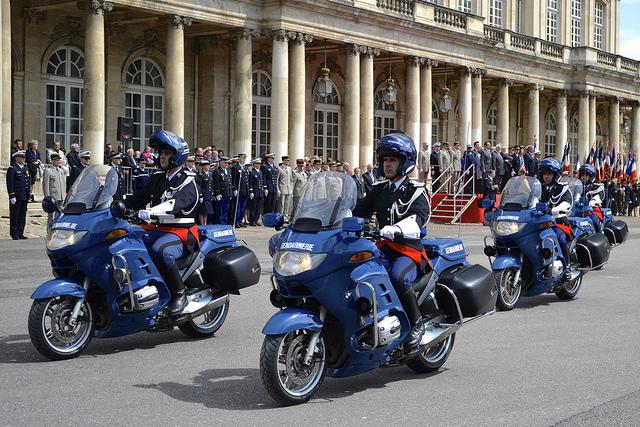What is the person riding?
Concise answer only. Motorcycle. What color are the motorcycles?
Give a very brief answer. Blue. What color are the gloves?
Concise answer only. White. 